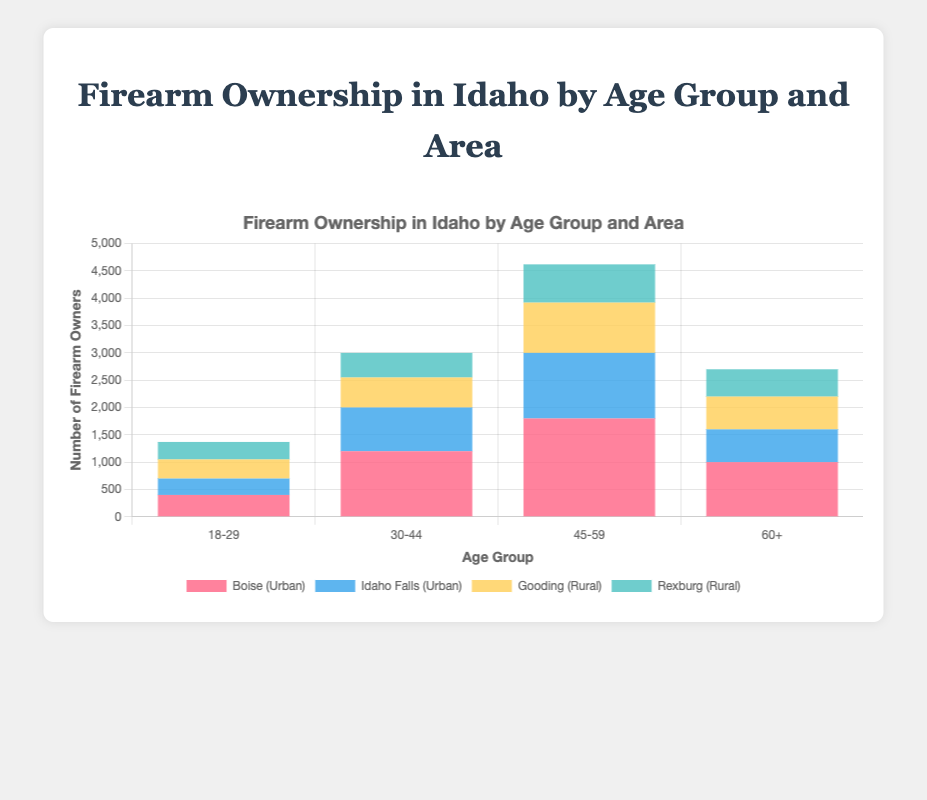Which age group has the highest firearm ownership in Boise? Examine the heights of the bars corresponding to each age group for Boise (red color). The tallest bar is for the age group 45-59, indicating the highest ownership.
Answer: 45-59 Which age group has the lowest firearm ownership in rural areas? Sum the heights of all rural areas (yellow for Gooding and green for Rexburg) across the age groups. The group 18-29 has 350 (Gooding) + 320 (Rexburg) = 670, which is the lowest total among the age groups.
Answer: 18-29 What is the total firearm ownership in Idaho Falls across all age groups? Add up the ownership numbers in Idaho Falls (light blue color) across all age groups: 300 (18-29) + 800 (30-44) + 1200 (45-59) + 600 (60+). This gives 300 + 800 + 1200 + 600 = 2900.
Answer: 2900 Compare firearm ownership between the urban and rural areas for the age group 30-44. Sum the ownership numbers for urban areas (Boise + Idaho Falls) and rural areas (Gooding + Rexburg) for the 30-44 group. Urban: 1200 (Boise) + 800 (Idaho Falls) = 2000; Rural: 550 (Gooding) + 450 (Rexburg) = 1000. Urban ownership is higher.
Answer: Urban > Rural What is the average firearm ownership in rural areas for the age group 45-59? Sum the ownership numbers for Gooding and Rexburg in the 45-59 age group: 920 (Gooding) + 700 (Rexburg) = 1620. Divide by 2 (number of rural areas): 1620 / 2 = 810.
Answer: 810 Compare the total firearm ownership in Boise to Gooding across all age groups. Sum the ownership numbers in Boise and Gooding over all age groups: Boise: 400 (18-29) + 1200 (30-44) + 1800 (45-59) + 1000 (60+) = 4400; Gooding: 350 (18-29) + 550 (30-44) + 920 (45-59) + 600 (60+) = 2420. Boise has higher ownership.
Answer: Boise > Gooding Which area has the least firearm ownership in the age group 60+? Examine the heights of the bars for the 60+ age group. The shortest bar is for Rexburg (green), indicating the least ownership.
Answer: Rexburg What is the visual representation of firearm ownership for the age group 18-29 in urban areas? Observe the bars for Boise (red) and Idaho Falls (light blue) in the 18-29 age group. The red bar is shorter than the light blue bar, indicating lower ownership in Boise compared to Idaho Falls.
Answer: Boise < Idaho Falls 